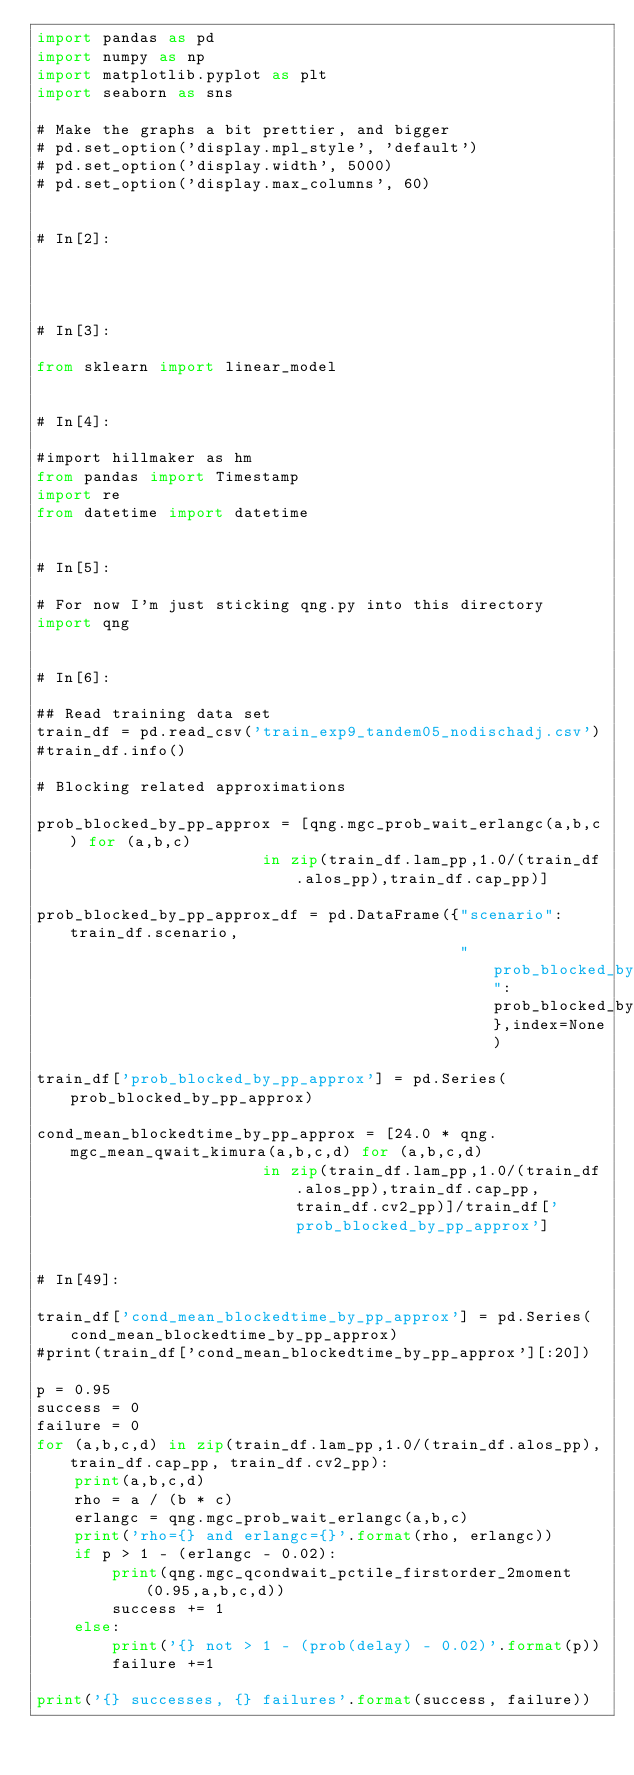<code> <loc_0><loc_0><loc_500><loc_500><_Python_>import pandas as pd
import numpy as np
import matplotlib.pyplot as plt
import seaborn as sns

# Make the graphs a bit prettier, and bigger
# pd.set_option('display.mpl_style', 'default')
# pd.set_option('display.width', 5000)
# pd.set_option('display.max_columns', 60)


# In[2]:




# In[3]:

from sklearn import linear_model


# In[4]:

#import hillmaker as hm
from pandas import Timestamp
import re
from datetime import datetime


# In[5]:

# For now I'm just sticking qng.py into this directory
import qng


# In[6]:

## Read training data set
train_df = pd.read_csv('train_exp9_tandem05_nodischadj.csv')
#train_df.info()

# Blocking related approximations

prob_blocked_by_pp_approx = [qng.mgc_prob_wait_erlangc(a,b,c) for (a,b,c)
                        in zip(train_df.lam_pp,1.0/(train_df.alos_pp),train_df.cap_pp)]

prob_blocked_by_pp_approx_df = pd.DataFrame({"scenario":train_df.scenario,
                                             "prob_blocked_by_pp_approx":prob_blocked_by_pp_approx},index=None)

train_df['prob_blocked_by_pp_approx'] = pd.Series(prob_blocked_by_pp_approx)

cond_mean_blockedtime_by_pp_approx = [24.0 * qng.mgc_mean_qwait_kimura(a,b,c,d) for (a,b,c,d)
                        in zip(train_df.lam_pp,1.0/(train_df.alos_pp),train_df.cap_pp, train_df.cv2_pp)]/train_df['prob_blocked_by_pp_approx']


# In[49]:

train_df['cond_mean_blockedtime_by_pp_approx'] = pd.Series(cond_mean_blockedtime_by_pp_approx)
#print(train_df['cond_mean_blockedtime_by_pp_approx'][:20])

p = 0.95
success = 0
failure = 0
for (a,b,c,d) in zip(train_df.lam_pp,1.0/(train_df.alos_pp),train_df.cap_pp, train_df.cv2_pp):
    print(a,b,c,d)
    rho = a / (b * c)
    erlangc = qng.mgc_prob_wait_erlangc(a,b,c)
    print('rho={} and erlangc={}'.format(rho, erlangc))
    if p > 1 - (erlangc - 0.02):
        print(qng.mgc_qcondwait_pctile_firstorder_2moment(0.95,a,b,c,d))
        success += 1
    else:
        print('{} not > 1 - (prob(delay) - 0.02)'.format(p))
        failure +=1

print('{} successes, {} failures'.format(success, failure))
</code> 